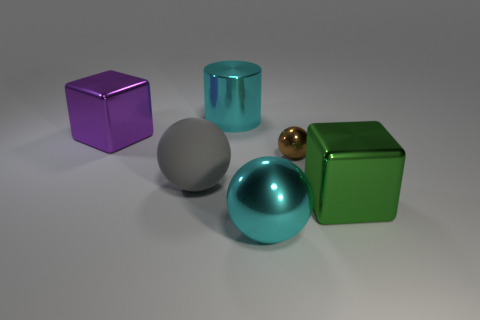Subtract all cylinders. How many objects are left? 5 Add 2 tiny blue metal spheres. How many objects exist? 8 Add 4 small shiny things. How many small shiny things are left? 5 Add 3 tiny blue metal spheres. How many tiny blue metal spheres exist? 3 Subtract 0 blue spheres. How many objects are left? 6 Subtract all brown spheres. Subtract all big metallic cubes. How many objects are left? 3 